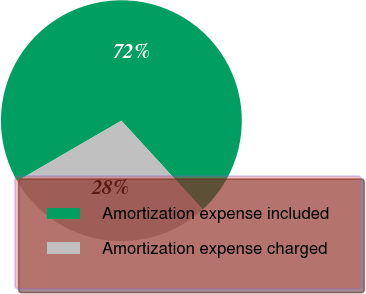<chart> <loc_0><loc_0><loc_500><loc_500><pie_chart><fcel>Amortization expense included<fcel>Amortization expense charged<nl><fcel>71.56%<fcel>28.44%<nl></chart> 